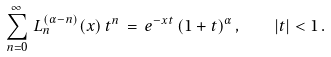Convert formula to latex. <formula><loc_0><loc_0><loc_500><loc_500>\sum _ { n = 0 } ^ { \infty } \, L _ { n } ^ { ( \alpha - n ) } ( x ) \, t ^ { n } \, = \, e ^ { - x t } \, ( 1 + t ) ^ { \alpha } \, , \quad | t | < 1 \, .</formula> 